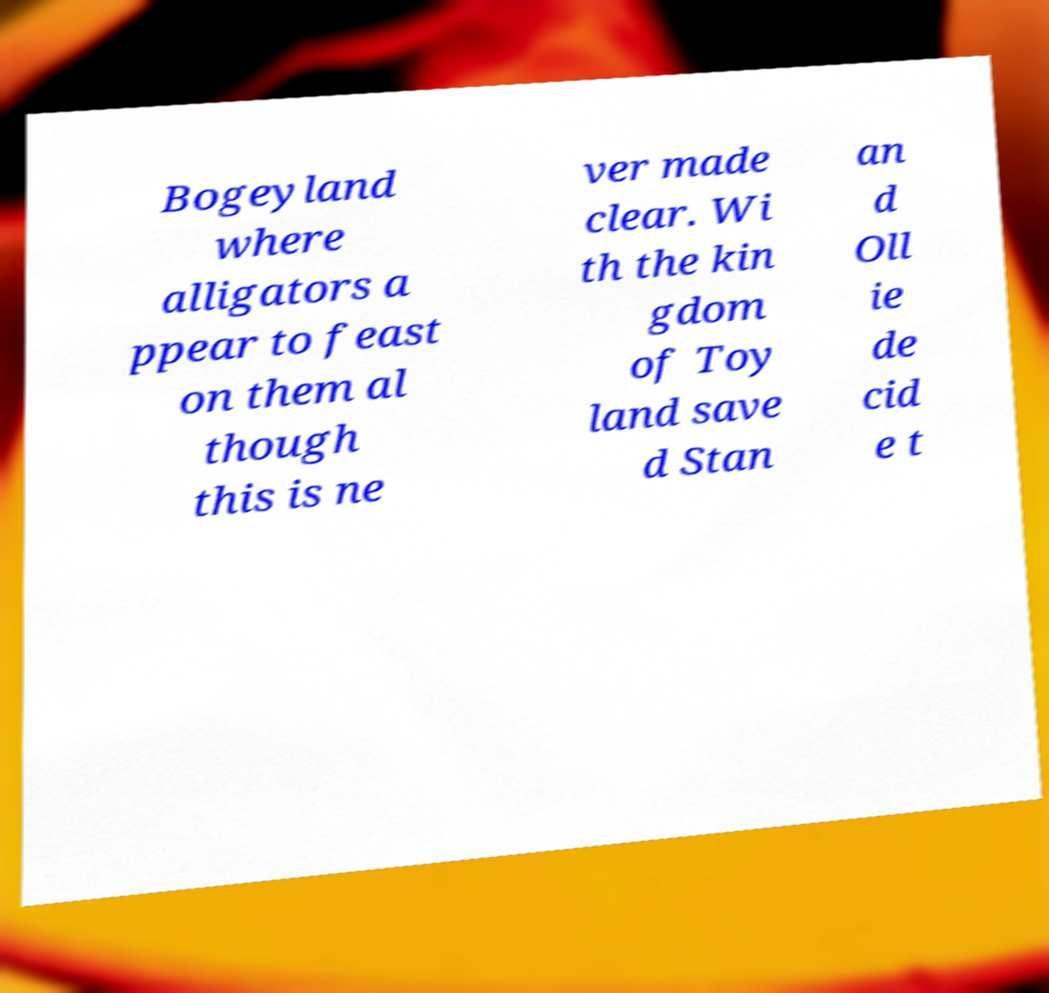Could you extract and type out the text from this image? Bogeyland where alligators a ppear to feast on them al though this is ne ver made clear. Wi th the kin gdom of Toy land save d Stan an d Oll ie de cid e t 